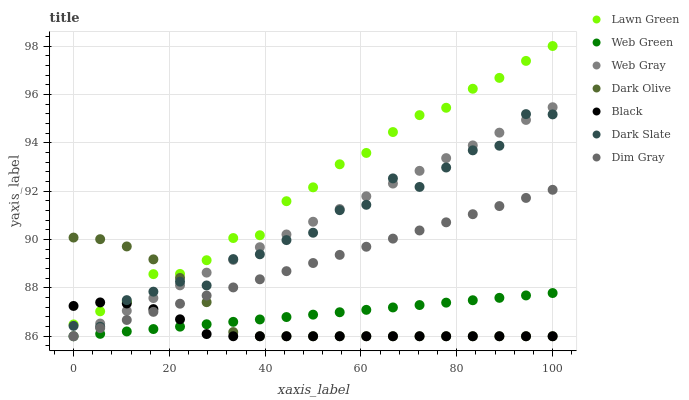Does Black have the minimum area under the curve?
Answer yes or no. Yes. Does Lawn Green have the maximum area under the curve?
Answer yes or no. Yes. Does Web Gray have the minimum area under the curve?
Answer yes or no. No. Does Web Gray have the maximum area under the curve?
Answer yes or no. No. Is Web Gray the smoothest?
Answer yes or no. Yes. Is Dark Slate the roughest?
Answer yes or no. Yes. Is Dark Olive the smoothest?
Answer yes or no. No. Is Dark Olive the roughest?
Answer yes or no. No. Does Web Gray have the lowest value?
Answer yes or no. Yes. Does Dark Slate have the lowest value?
Answer yes or no. No. Does Lawn Green have the highest value?
Answer yes or no. Yes. Does Web Gray have the highest value?
Answer yes or no. No. Is Web Green less than Dark Slate?
Answer yes or no. Yes. Is Lawn Green greater than Web Green?
Answer yes or no. Yes. Does Dark Olive intersect Dark Slate?
Answer yes or no. Yes. Is Dark Olive less than Dark Slate?
Answer yes or no. No. Is Dark Olive greater than Dark Slate?
Answer yes or no. No. Does Web Green intersect Dark Slate?
Answer yes or no. No. 